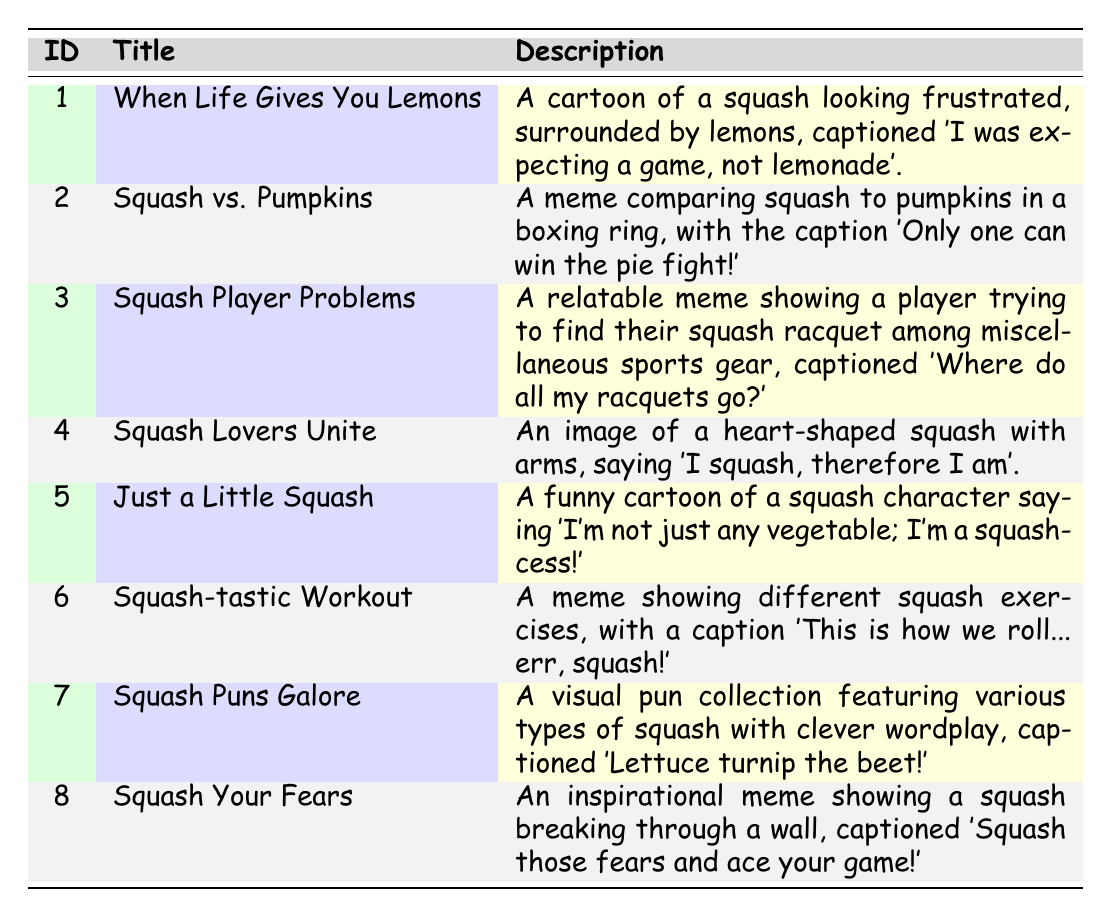What is the title of the meme with ID 3? The title of the meme with ID 3 can be found directly in the table under the "Title" column. For ID 3, the title is "Squash Player Problems."
Answer: Squash Player Problems How many memes have been shared on Instagram? To find this, we count the instances in the "platforms_shared" column where "Instagram" is mentioned. The memes shared on Instagram are: "When Life Gives You Lemons," "Squash Lovers Unite," "Squash-tastic Workout," "Squash Puns Galore," and "Squash Your Fears." This makes a total of 5 memes.
Answer: 5 Is "Just a Little Squash" available on Facebook? To answer this, we check the "platforms_shared" column for the meme titled "Just a Little Squash." The platforms listed for this meme are "Twitter" and "Reddit," indicating it is not available on Facebook. Therefore, the answer is no.
Answer: No Which meme was created on the latest date? To find this, we look at the "creation_date" column and identify the most recent date. The entry "Squash Your Fears" has the creation date of "2023-10-01," which is the latest date compared to all other memes.
Answer: Squash Your Fears How many memes feature squash in a humorous context compared to inspirational context? First, we define the contexts: humorous memes include titles like "When Life Gives You Lemons," "Squash vs. Pumpkins," "Squash Player Problems," "Just a Little Squash," and "Squash Puns Galore," which totals to 5. Inspirational memes include "Squash Lovers Unite," "Squash-tastic Workout," and "Squash Your Fears," totaling 3. The difference is 5 humorous memes - 3 inspirational memes = 2 more humorous memes.
Answer: 2 Which meme has the caption "I squash, therefore I am"? This caption appears in the description for the meme titled "Squash Lovers Unite," which identifies it in the table under the "Description" column.
Answer: Squash Lovers Unite List all platforms where "Squash vs. Pumpkins" was shared. By checking the "platforms_shared" column for the meme titled "Squash vs. Pumpkins," we see it was shared on "Instagram" and "Reddit."
Answer: Instagram, Reddit Are there any memes shared on both Twitter and Instagram? To answer this, we check the "platforms_shared" for all memes to see which ones include both platforms. The memes "Squash Your Fears," "Squash Lovers Unite," and "Squash Player Problems" are shared on both. Thus, the answer is yes.
Answer: Yes 